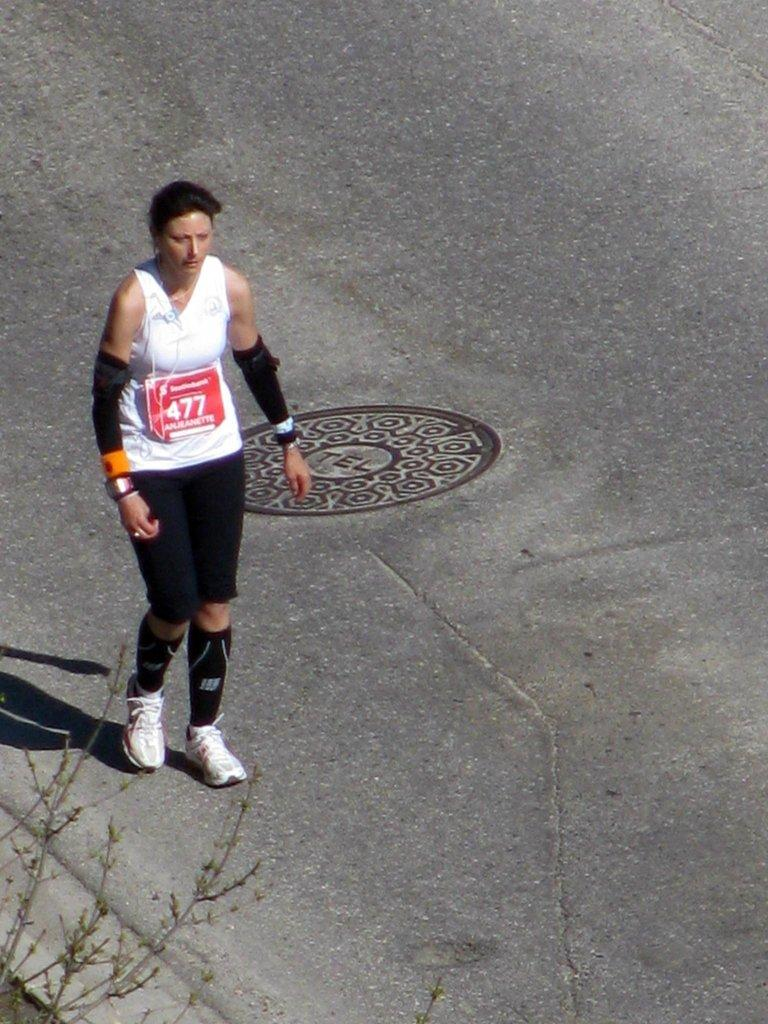Who is present in the image? There is a woman in the image. What is the woman doing in the image? The woman is standing in the image. What is the woman wearing on her feet? The woman is wearing shoes in the image. What color is the woman's clothing on the right side of her body? The woman is wearing a red board, which could be a red dress or coat. What type of vegetation can be seen on the left side of the image? There are plants on the left side of the image. How many cabbages are visible in the image? There are no cabbages present in the image. What memory does the woman have about the frogs in the image? There are no frogs present in the image, so it is not possible to determine any memories related to them. 